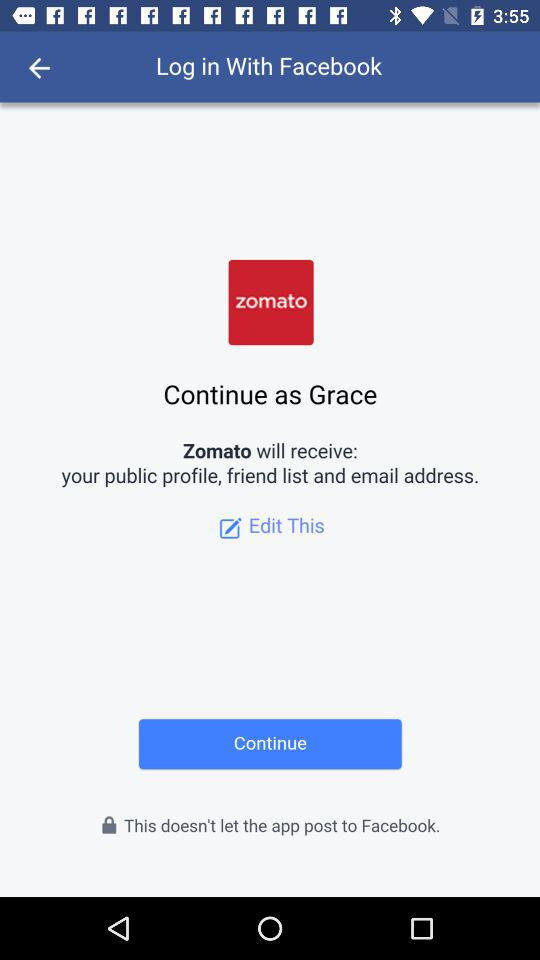Which application will receive your public profile and email address? The application is "Zomato". 